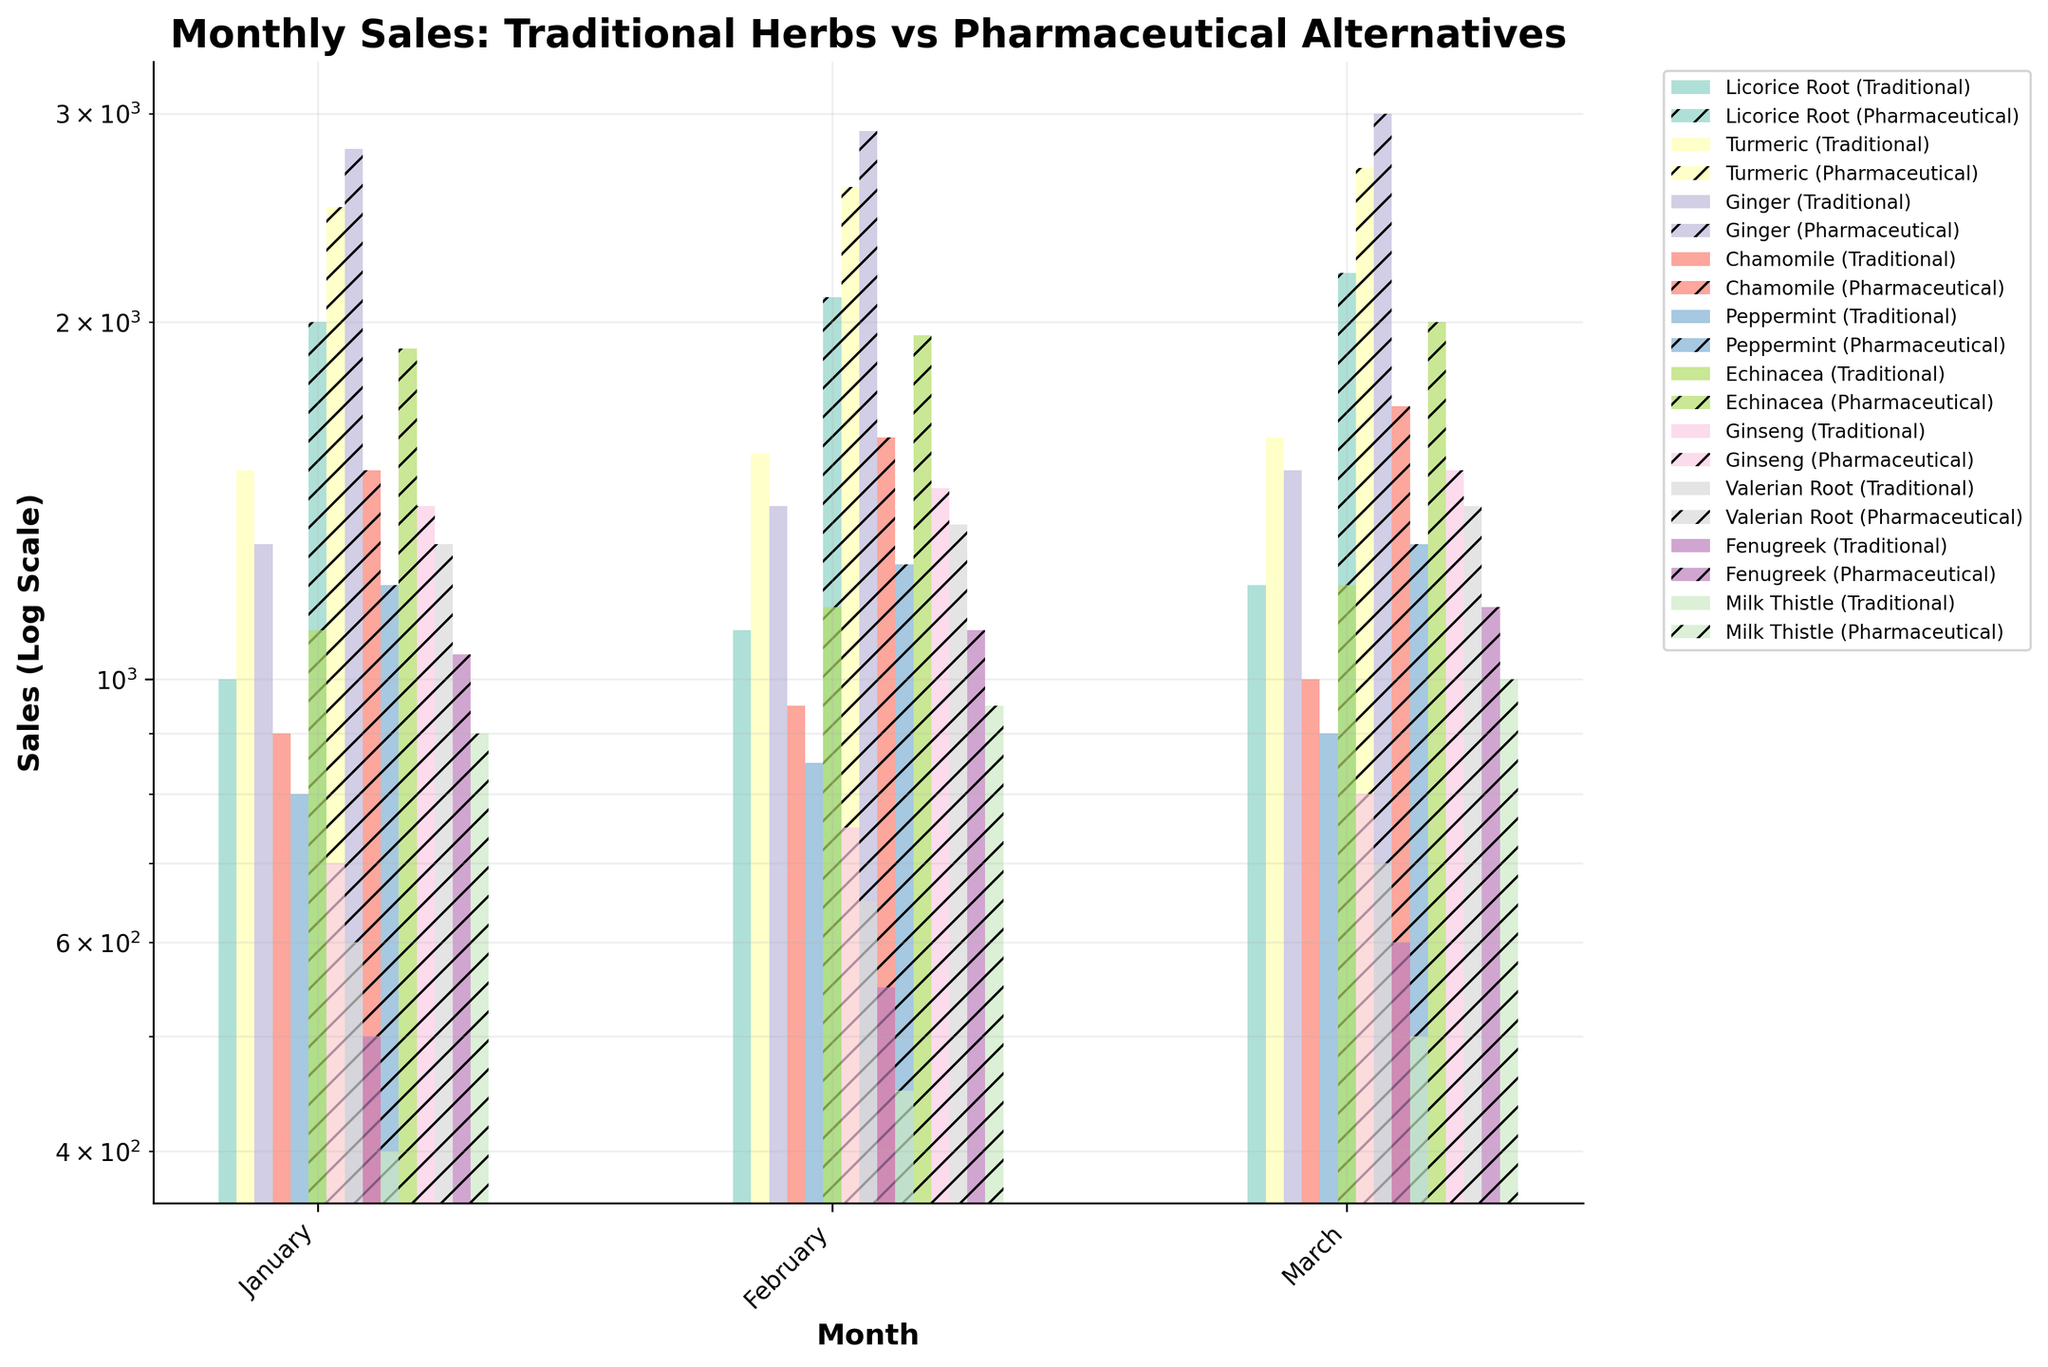What is the title of the plot? Look at the top center of the plot where the title is present. It reads: "Monthly Sales: Traditional Herbs vs Pharmaceutical Alternatives".
Answer: Monthly Sales: Traditional Herbs vs Pharmaceutical Alternatives Which month had the highest sales for Ginger (Traditional)? Examine the bars for Ginger (Traditional) in the January, February, and March groupings to identify the tallest bar, which represents the highest sales. The highest sales for Ginger (Traditional) are in March.
Answer: March Which herb had the lowest sales for its pharmaceutical alternative in February? Compare the heights of the pharmaceutical alternative bars for all herbs in February. The shortest bar in February, representing the lowest sales, corresponds to Milk Thistle.
Answer: Milk Thistle What is the overall trend in sales for Turmeric (Traditional) from January to March? Observe the bars representing Turmeric (Traditional) from January through March. The height of the bars increases from January to March, showing an upward trend.
Answer: Upward trend Which herbal alternative had the closest sales to its pharmaceutical counterpart in January? Compare the heights of the traditional vs. pharmaceutical bars side-by-side for each herb in January. The herbal alternative that is closest to its pharmaceutical counterpart in terms of bar height is Licorice Root.
Answer: Licorice Root How do the sales of Echinacea (Traditional) in February compare to the sales of Valerian Root (Pharmaceutical) in the same month? Check the heights of the Echinacea (Traditional) and Valerian Root (Pharmaceutical) bars in February and compare them. In February, Echinacea (Traditional) has higher sales compared to Valerian Root (Pharmaceutical).
Answer: Echinacea (Traditional) has higher sales How did the sales of Pharmaceutical Alternatives change from January to March for Fenugreek? Observe the bars for the pharmaceutical alternative of Fenugreek from January to March. The heights of the bars show an increasing trend from January to March.
Answer: Increasing trend What is the color used to represent the pharmaceutical alternatives in the plot? The pharmaceutical alternatives are represented by bars with a distinctive visual pattern, specifically hatch marks ('//'), overlaid on colors from the color palette.
Answer: Colors with hatch marks (//) By how much did sales of Valerian Root (Traditional) change from February to March? Calculate the difference between the heights of the Valerian Root (Traditional) bars in February and March. Traditional sales in February are 650 and in March, they are 700; the change is 700 - 650 = 50.
Answer: 50 Is the difference in sales between Traditional and Pharmaceutical highest for which herb in March? Compare the difference in bar heights between the traditional and pharmaceutical alternatives for each herb in March. The highest difference is observed in Ginger.
Answer: Ginger 